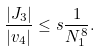Convert formula to latex. <formula><loc_0><loc_0><loc_500><loc_500>\frac { | J _ { 3 } | } { | v _ { 4 } | } \leq s \frac { 1 } { N _ { 1 } ^ { 8 } } .</formula> 